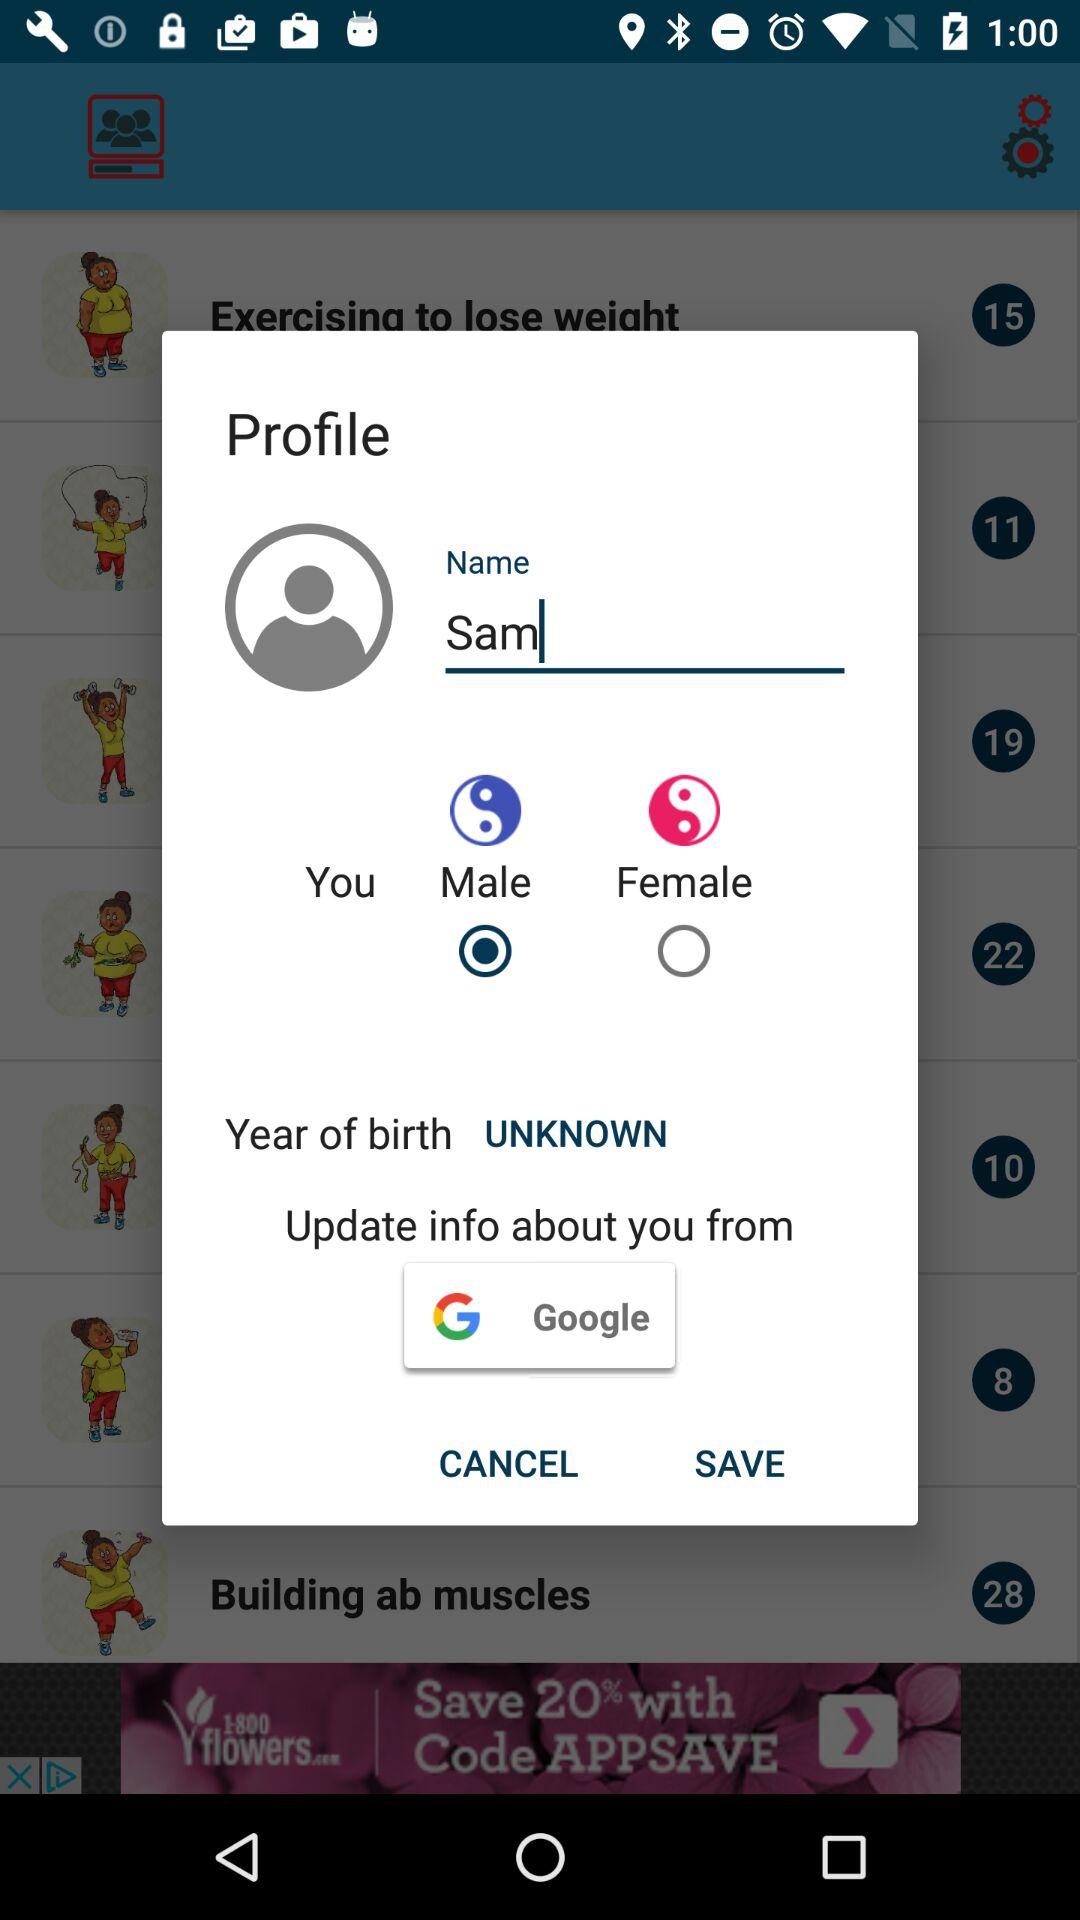How tall is Sam?
When the provided information is insufficient, respond with <no answer>. <no answer> 